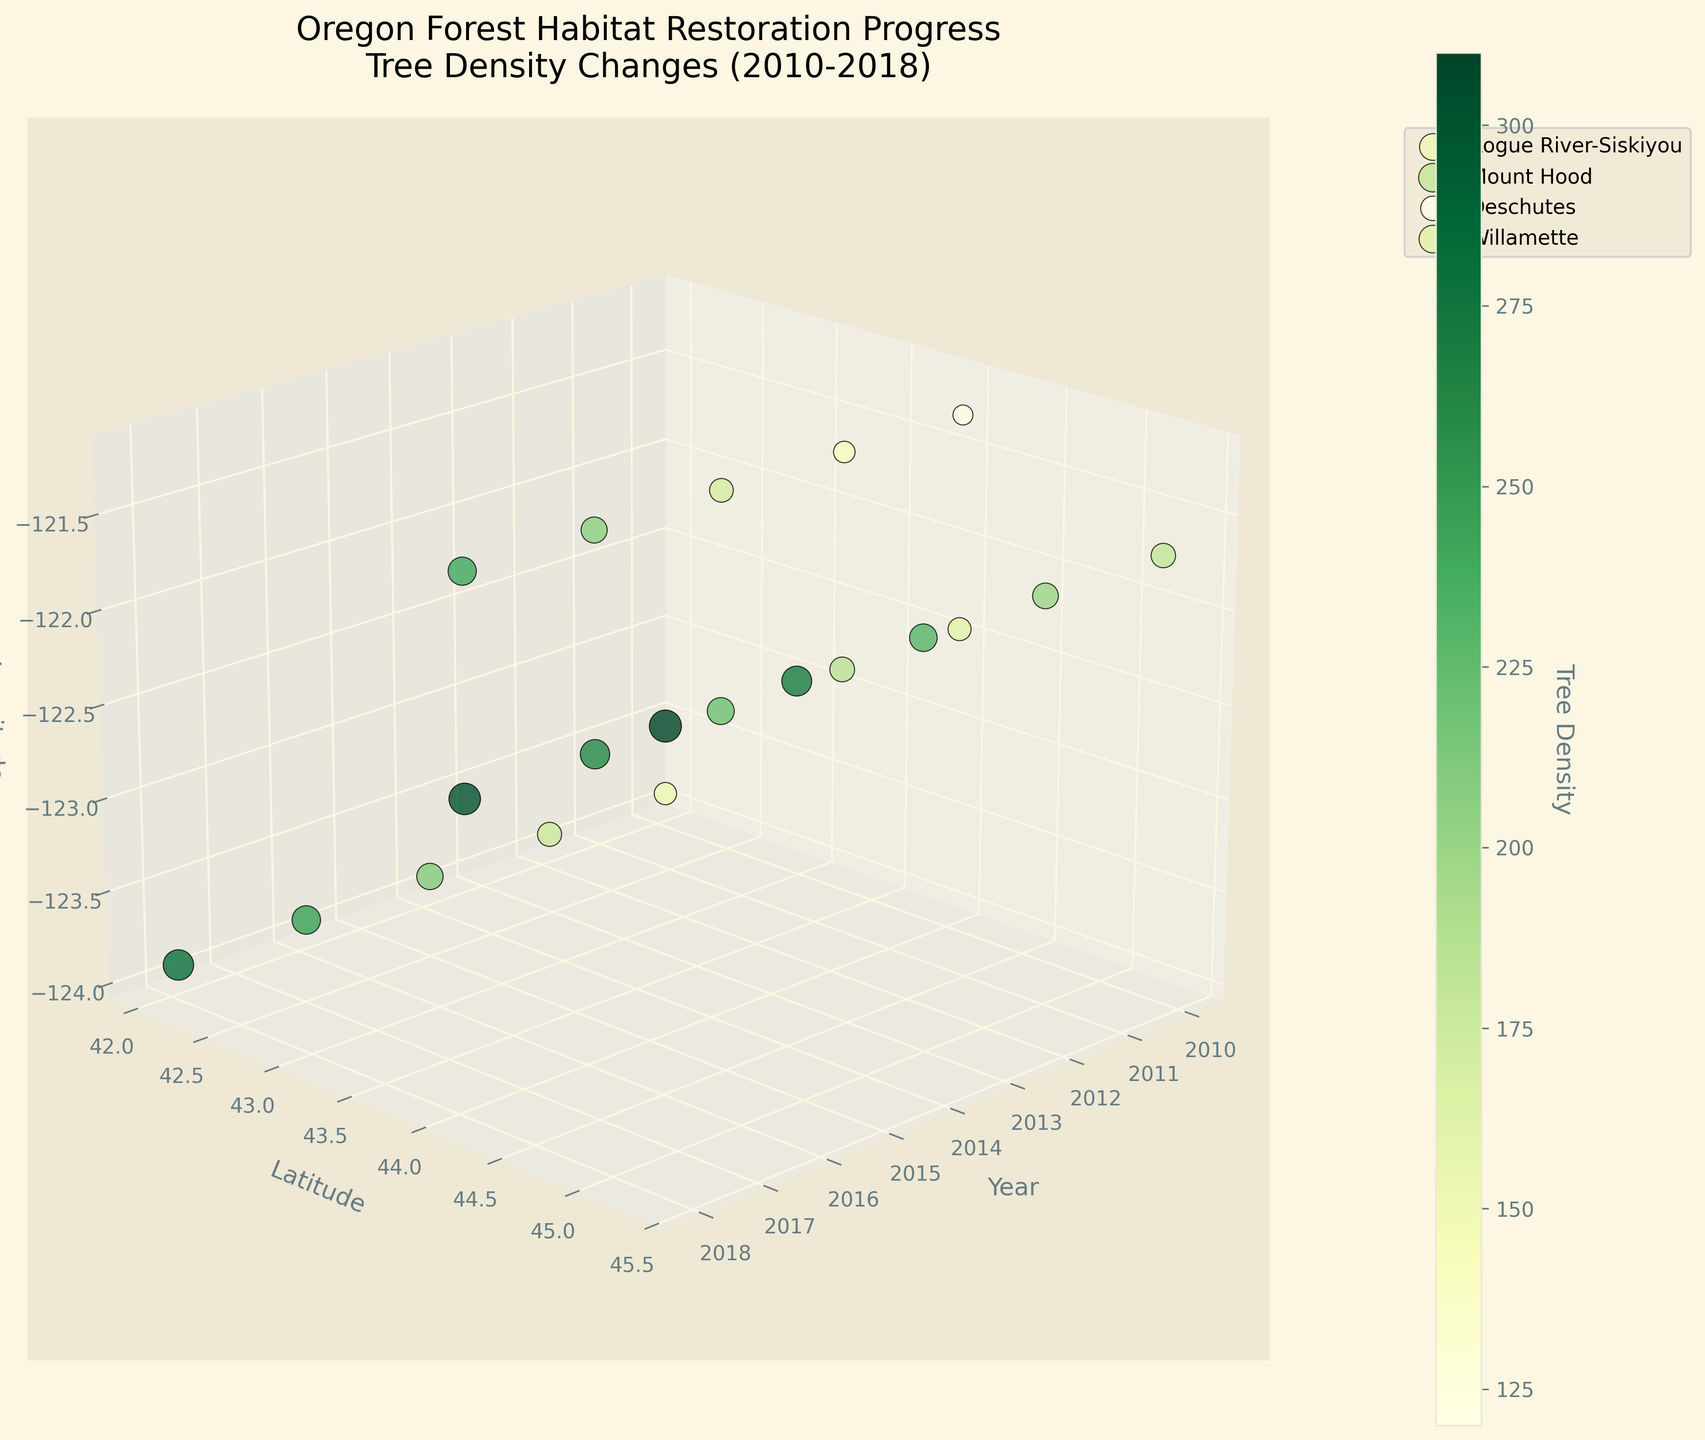What is the title of the figure? The title is usually placed at the top of the figure and is formatted to provide a summary of the data being visualized. In this case, it mentions "Oregon Forest Habitat Restoration Progress" and specifies the time frame of "Tree Density Changes (2010-2018)"
Answer: Oregon Forest Habitat Restoration Progress: Tree Density Changes (2010-2018) How many regions are shown in the figure? By observing the legend, which categorizes different regions and their corresponding colors, one can count the distinct entries.
Answer: Four regions Which region has the highest tree density in 2018? By examining the color intensity and size of the points corresponding to 2018, one can identify which region has the highest tree density. The color bar provides a reference for interpreting tree density values.
Answer: Willamette What are the axes of the 3D plot? By reading the labels next to each axis, you can identify what each axis represents in the plot.
Answer: Year, Latitude, Longitude Compare the tree density changes from 2010 to 2018 between Rogue River-Siskiyou and Mount Hood. Which region shows a higher increase? To answer this, subtract the 2010 tree density value from the 2018 value for both regions and then compare the differences.
Answer: Mount Hood What is the pattern of tree density change in the Deschutes region? By tracking the points representing the Deschutes region across the years, one can observe the trend in tree density.
Answer: It increases steadily over time Identify the data point with the lowest tree density in the Rogue River-Siskiyou region and state its year. You need to find the smallest tree density value among the points of the Rogue River-Siskiyou region and note its corresponding year.
Answer: 2010 How does the latitude of the Mount Hood region compare to the Deschutes region? By looking at their positions along the latitude (Y) axis, you can compare the two regions' latitudes.
Answer: Mount Hood has a higher latitude than Deschutes What color scheme is used for the tree density values? You can determine this by observing the color bar that indicates the color progression used for tree density values.
Answer: YlGn (Yellow-Green) What is the latitude of the Willamette region? Locate the points corresponding to the Willamette region and note their position along the latitude (Y) axis.
Answer: 44.0582 